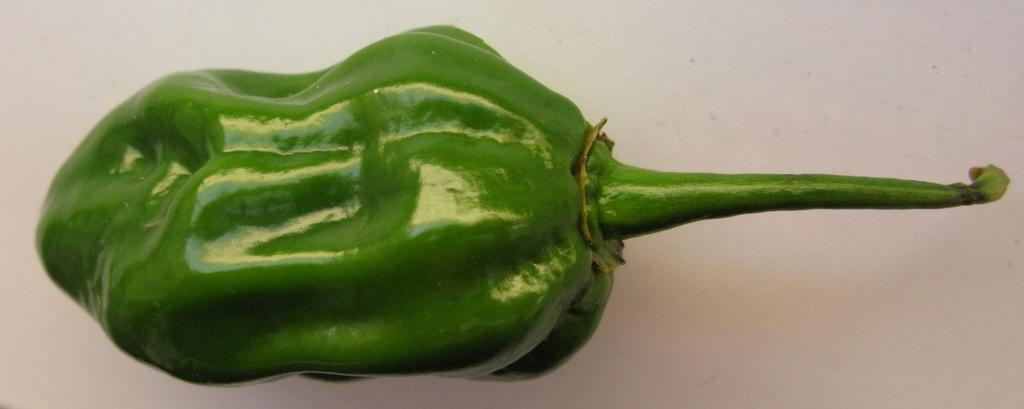What is the main subject of the image? There is a capsicum in the center of the image. What type of paper can be seen covering the capsicum in the image? There is no paper present in the image; it only features a capsicum. Can you describe the boundary of the capsicum in the image? The image only shows a capsicum, and there is no boundary mentioned or visible in the image. 